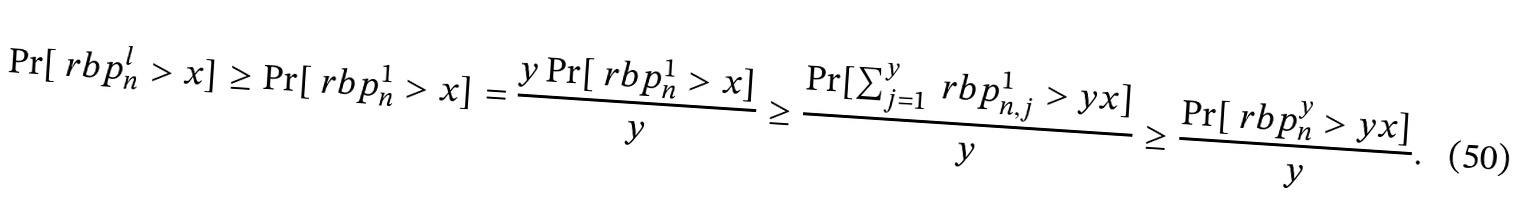Convert formula to latex. <formula><loc_0><loc_0><loc_500><loc_500>\Pr [ \ r b p _ { n } ^ { l } > x ] & \geq \Pr [ \ r b p _ { n } ^ { 1 } > x ] = \frac { y \Pr [ \ r b p _ { n } ^ { 1 } > x ] } { y } \geq \frac { \Pr [ \sum _ { j = 1 } ^ { y } \ r b p _ { n , j } ^ { 1 } > y x ] } { y } \geq \frac { \Pr [ \ r b p _ { n } ^ { y } > y x ] } { y } .</formula> 